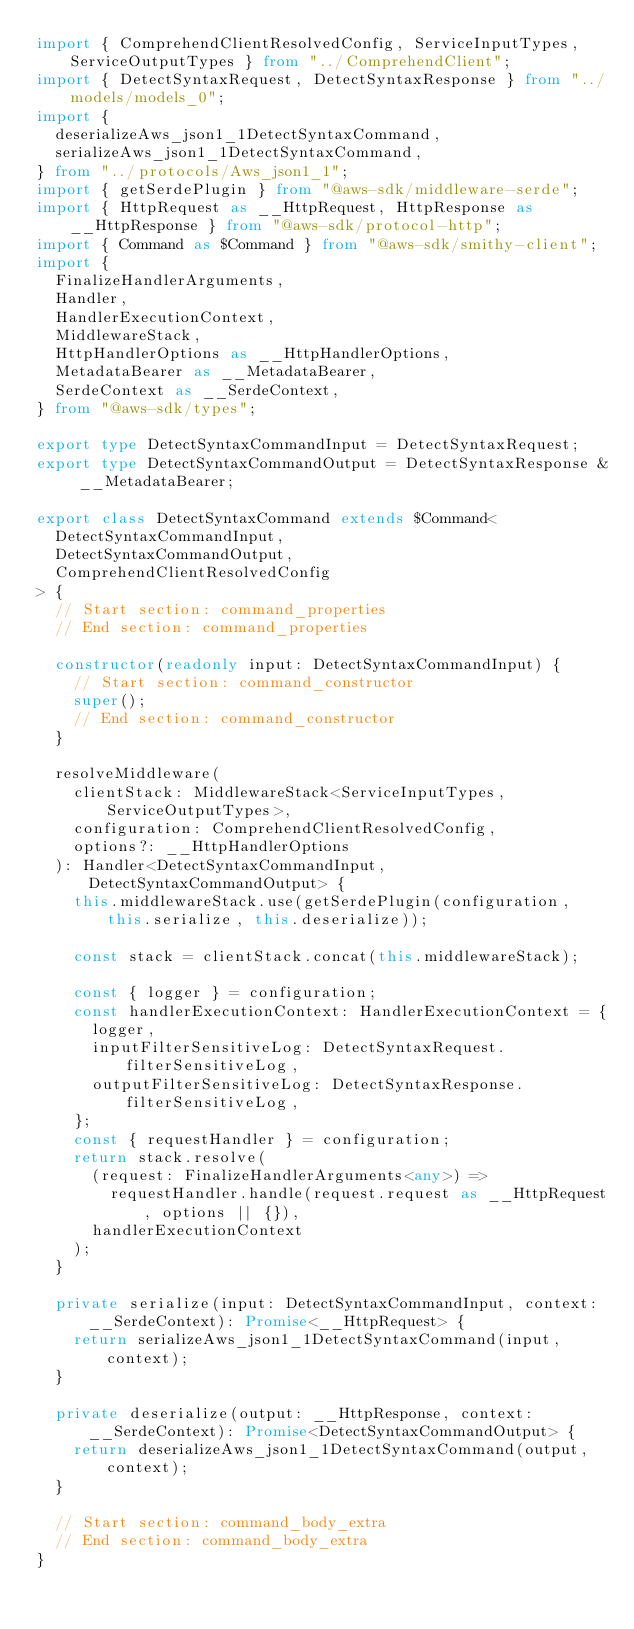Convert code to text. <code><loc_0><loc_0><loc_500><loc_500><_TypeScript_>import { ComprehendClientResolvedConfig, ServiceInputTypes, ServiceOutputTypes } from "../ComprehendClient";
import { DetectSyntaxRequest, DetectSyntaxResponse } from "../models/models_0";
import {
  deserializeAws_json1_1DetectSyntaxCommand,
  serializeAws_json1_1DetectSyntaxCommand,
} from "../protocols/Aws_json1_1";
import { getSerdePlugin } from "@aws-sdk/middleware-serde";
import { HttpRequest as __HttpRequest, HttpResponse as __HttpResponse } from "@aws-sdk/protocol-http";
import { Command as $Command } from "@aws-sdk/smithy-client";
import {
  FinalizeHandlerArguments,
  Handler,
  HandlerExecutionContext,
  MiddlewareStack,
  HttpHandlerOptions as __HttpHandlerOptions,
  MetadataBearer as __MetadataBearer,
  SerdeContext as __SerdeContext,
} from "@aws-sdk/types";

export type DetectSyntaxCommandInput = DetectSyntaxRequest;
export type DetectSyntaxCommandOutput = DetectSyntaxResponse & __MetadataBearer;

export class DetectSyntaxCommand extends $Command<
  DetectSyntaxCommandInput,
  DetectSyntaxCommandOutput,
  ComprehendClientResolvedConfig
> {
  // Start section: command_properties
  // End section: command_properties

  constructor(readonly input: DetectSyntaxCommandInput) {
    // Start section: command_constructor
    super();
    // End section: command_constructor
  }

  resolveMiddleware(
    clientStack: MiddlewareStack<ServiceInputTypes, ServiceOutputTypes>,
    configuration: ComprehendClientResolvedConfig,
    options?: __HttpHandlerOptions
  ): Handler<DetectSyntaxCommandInput, DetectSyntaxCommandOutput> {
    this.middlewareStack.use(getSerdePlugin(configuration, this.serialize, this.deserialize));

    const stack = clientStack.concat(this.middlewareStack);

    const { logger } = configuration;
    const handlerExecutionContext: HandlerExecutionContext = {
      logger,
      inputFilterSensitiveLog: DetectSyntaxRequest.filterSensitiveLog,
      outputFilterSensitiveLog: DetectSyntaxResponse.filterSensitiveLog,
    };
    const { requestHandler } = configuration;
    return stack.resolve(
      (request: FinalizeHandlerArguments<any>) =>
        requestHandler.handle(request.request as __HttpRequest, options || {}),
      handlerExecutionContext
    );
  }

  private serialize(input: DetectSyntaxCommandInput, context: __SerdeContext): Promise<__HttpRequest> {
    return serializeAws_json1_1DetectSyntaxCommand(input, context);
  }

  private deserialize(output: __HttpResponse, context: __SerdeContext): Promise<DetectSyntaxCommandOutput> {
    return deserializeAws_json1_1DetectSyntaxCommand(output, context);
  }

  // Start section: command_body_extra
  // End section: command_body_extra
}
</code> 